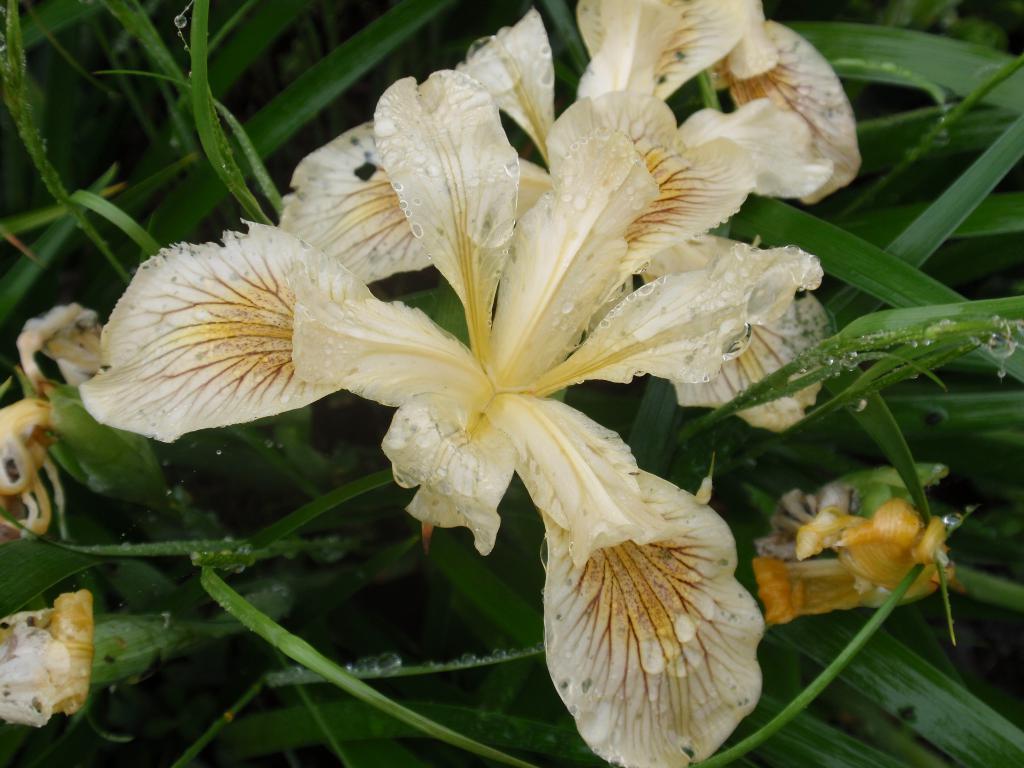Describe this image in one or two sentences. In this image in the foreground there are some flowers, and in the background there are some plants. 